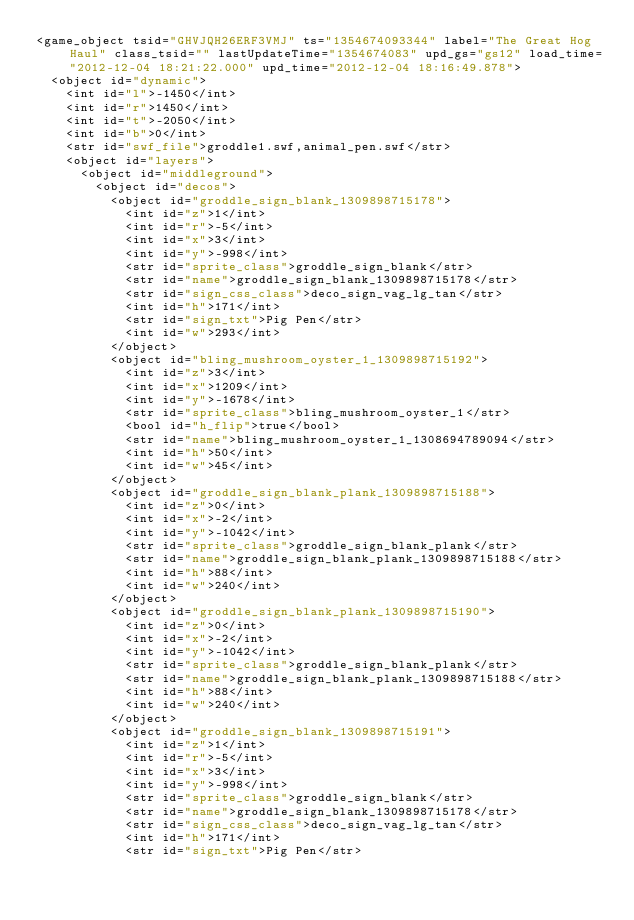Convert code to text. <code><loc_0><loc_0><loc_500><loc_500><_XML_><game_object tsid="GHVJQH26ERF3VMJ" ts="1354674093344" label="The Great Hog Haul" class_tsid="" lastUpdateTime="1354674083" upd_gs="gs12" load_time="2012-12-04 18:21:22.000" upd_time="2012-12-04 18:16:49.878">
	<object id="dynamic">
		<int id="l">-1450</int>
		<int id="r">1450</int>
		<int id="t">-2050</int>
		<int id="b">0</int>
		<str id="swf_file">groddle1.swf,animal_pen.swf</str>
		<object id="layers">
			<object id="middleground">
				<object id="decos">
					<object id="groddle_sign_blank_1309898715178">
						<int id="z">1</int>
						<int id="r">-5</int>
						<int id="x">3</int>
						<int id="y">-998</int>
						<str id="sprite_class">groddle_sign_blank</str>
						<str id="name">groddle_sign_blank_1309898715178</str>
						<str id="sign_css_class">deco_sign_vag_lg_tan</str>
						<int id="h">171</int>
						<str id="sign_txt">Pig Pen</str>
						<int id="w">293</int>
					</object>
					<object id="bling_mushroom_oyster_1_1309898715192">
						<int id="z">3</int>
						<int id="x">1209</int>
						<int id="y">-1678</int>
						<str id="sprite_class">bling_mushroom_oyster_1</str>
						<bool id="h_flip">true</bool>
						<str id="name">bling_mushroom_oyster_1_1308694789094</str>
						<int id="h">50</int>
						<int id="w">45</int>
					</object>
					<object id="groddle_sign_blank_plank_1309898715188">
						<int id="z">0</int>
						<int id="x">-2</int>
						<int id="y">-1042</int>
						<str id="sprite_class">groddle_sign_blank_plank</str>
						<str id="name">groddle_sign_blank_plank_1309898715188</str>
						<int id="h">88</int>
						<int id="w">240</int>
					</object>
					<object id="groddle_sign_blank_plank_1309898715190">
						<int id="z">0</int>
						<int id="x">-2</int>
						<int id="y">-1042</int>
						<str id="sprite_class">groddle_sign_blank_plank</str>
						<str id="name">groddle_sign_blank_plank_1309898715188</str>
						<int id="h">88</int>
						<int id="w">240</int>
					</object>
					<object id="groddle_sign_blank_1309898715191">
						<int id="z">1</int>
						<int id="r">-5</int>
						<int id="x">3</int>
						<int id="y">-998</int>
						<str id="sprite_class">groddle_sign_blank</str>
						<str id="name">groddle_sign_blank_1309898715178</str>
						<str id="sign_css_class">deco_sign_vag_lg_tan</str>
						<int id="h">171</int>
						<str id="sign_txt">Pig Pen</str></code> 